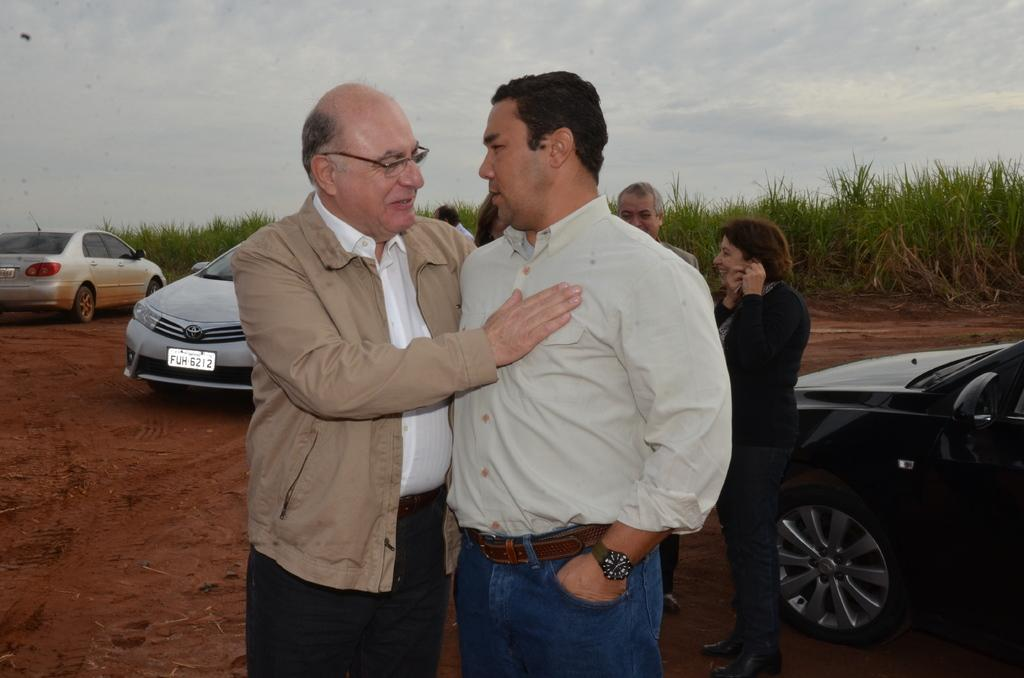How many men are in the foreground of the image? There are two men standing in the foreground of the image. What can be seen in the background of the image? People, cars, greenery, and the sky are visible in the background of the image. Can you describe the cloud at the top of the image? There is a cloud at the top of the image. What type of drum is being played by the giants in the image? There are no giants or drums present in the image. 